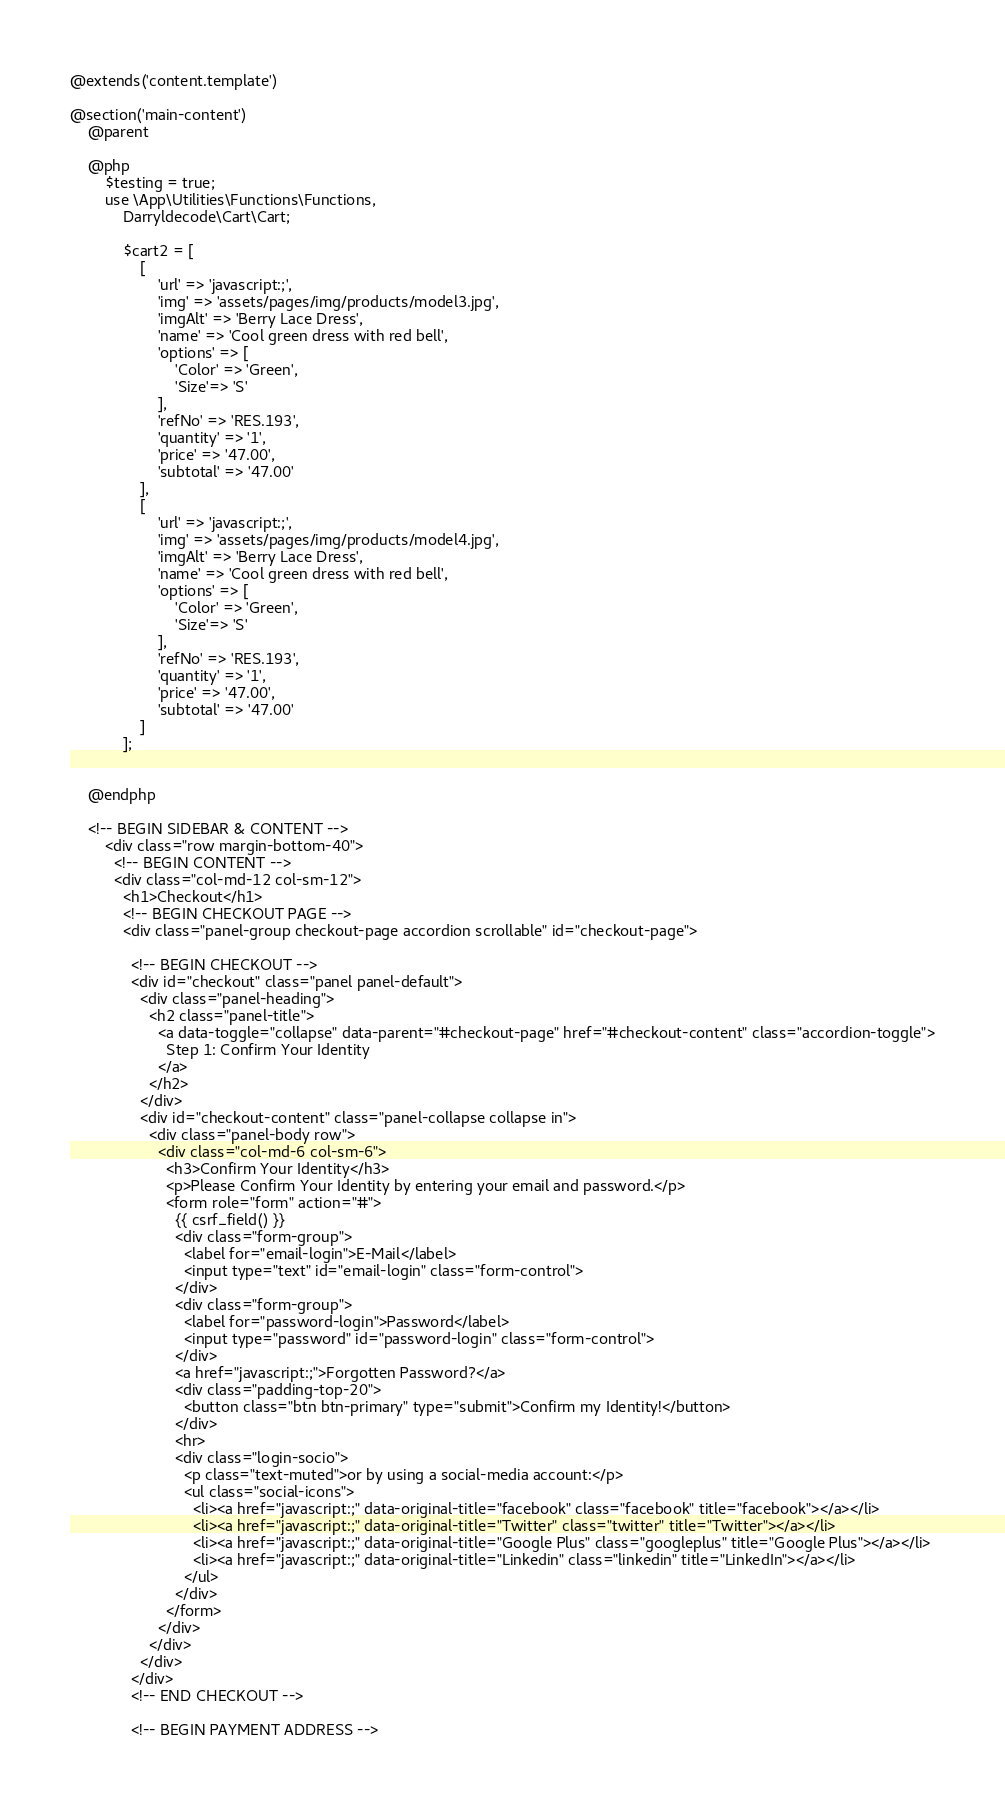<code> <loc_0><loc_0><loc_500><loc_500><_PHP_>
@extends('content.template')

@section('main-content')
    @parent 

    @php
        $testing = true;
        use \App\Utilities\Functions\Functions,
            Darryldecode\Cart\Cart;

            $cart2 = [
                [
                    'url' => 'javascript:;',    
                    'img' => 'assets/pages/img/products/model3.jpg',
                    'imgAlt' => 'Berry Lace Dress',
                    'name' => 'Cool green dress with red bell',
                    'options' => [
                        'Color' => 'Green', 
                        'Size'=> 'S'
                    ],
                    'refNo' => 'RES.193',
                    'quantity' => '1',
                    'price' => '47.00',
                    'subtotal' => '47.00'
                ],
                [
                    'url' => 'javascript:;',    
                    'img' => 'assets/pages/img/products/model4.jpg',
                    'imgAlt' => 'Berry Lace Dress',
                    'name' => 'Cool green dress with red bell',
                    'options' => [
                        'Color' => 'Green', 
                        'Size'=> 'S'
                    ],
                    'refNo' => 'RES.193',
                    'quantity' => '1',
                    'price' => '47.00',
                    'subtotal' => '47.00'
                ]
            ];
            

    @endphp

    <!-- BEGIN SIDEBAR & CONTENT -->
        <div class="row margin-bottom-40">
          <!-- BEGIN CONTENT -->
          <div class="col-md-12 col-sm-12">
            <h1>Checkout</h1>
            <!-- BEGIN CHECKOUT PAGE -->
            <div class="panel-group checkout-page accordion scrollable" id="checkout-page">

              <!-- BEGIN CHECKOUT -->
              <div id="checkout" class="panel panel-default">
                <div class="panel-heading">
                  <h2 class="panel-title">
                    <a data-toggle="collapse" data-parent="#checkout-page" href="#checkout-content" class="accordion-toggle">
                      Step 1: Confirm Your Identity
                    </a>
                  </h2>
                </div>
                <div id="checkout-content" class="panel-collapse collapse in">
                  <div class="panel-body row">
                    <div class="col-md-6 col-sm-6">
                      <h3>Confirm Your Identity</h3>
                      <p>Please Confirm Your Identity by entering your email and password.</p>
                      <form role="form" action="#">
                        {{ csrf_field() }}
                        <div class="form-group">
                          <label for="email-login">E-Mail</label>
                          <input type="text" id="email-login" class="form-control">
                        </div>
                        <div class="form-group">
                          <label for="password-login">Password</label>
                          <input type="password" id="password-login" class="form-control">
                        </div>
                        <a href="javascript:;">Forgotten Password?</a>
                        <div class="padding-top-20">                  
                          <button class="btn btn-primary" type="submit">Confirm my Identity!</button>
                        </div>
                        <hr>
                        <div class="login-socio">
                          <p class="text-muted">or by using a social-media account:</p>
                          <ul class="social-icons">
                            <li><a href="javascript:;" data-original-title="facebook" class="facebook" title="facebook"></a></li>
                            <li><a href="javascript:;" data-original-title="Twitter" class="twitter" title="Twitter"></a></li>
                            <li><a href="javascript:;" data-original-title="Google Plus" class="googleplus" title="Google Plus"></a></li>
                            <li><a href="javascript:;" data-original-title="Linkedin" class="linkedin" title="LinkedIn"></a></li>
                          </ul>
                        </div>
                      </form>
                    </div>
                  </div>
                </div>
              </div>
              <!-- END CHECKOUT -->

              <!-- BEGIN PAYMENT ADDRESS --></code> 